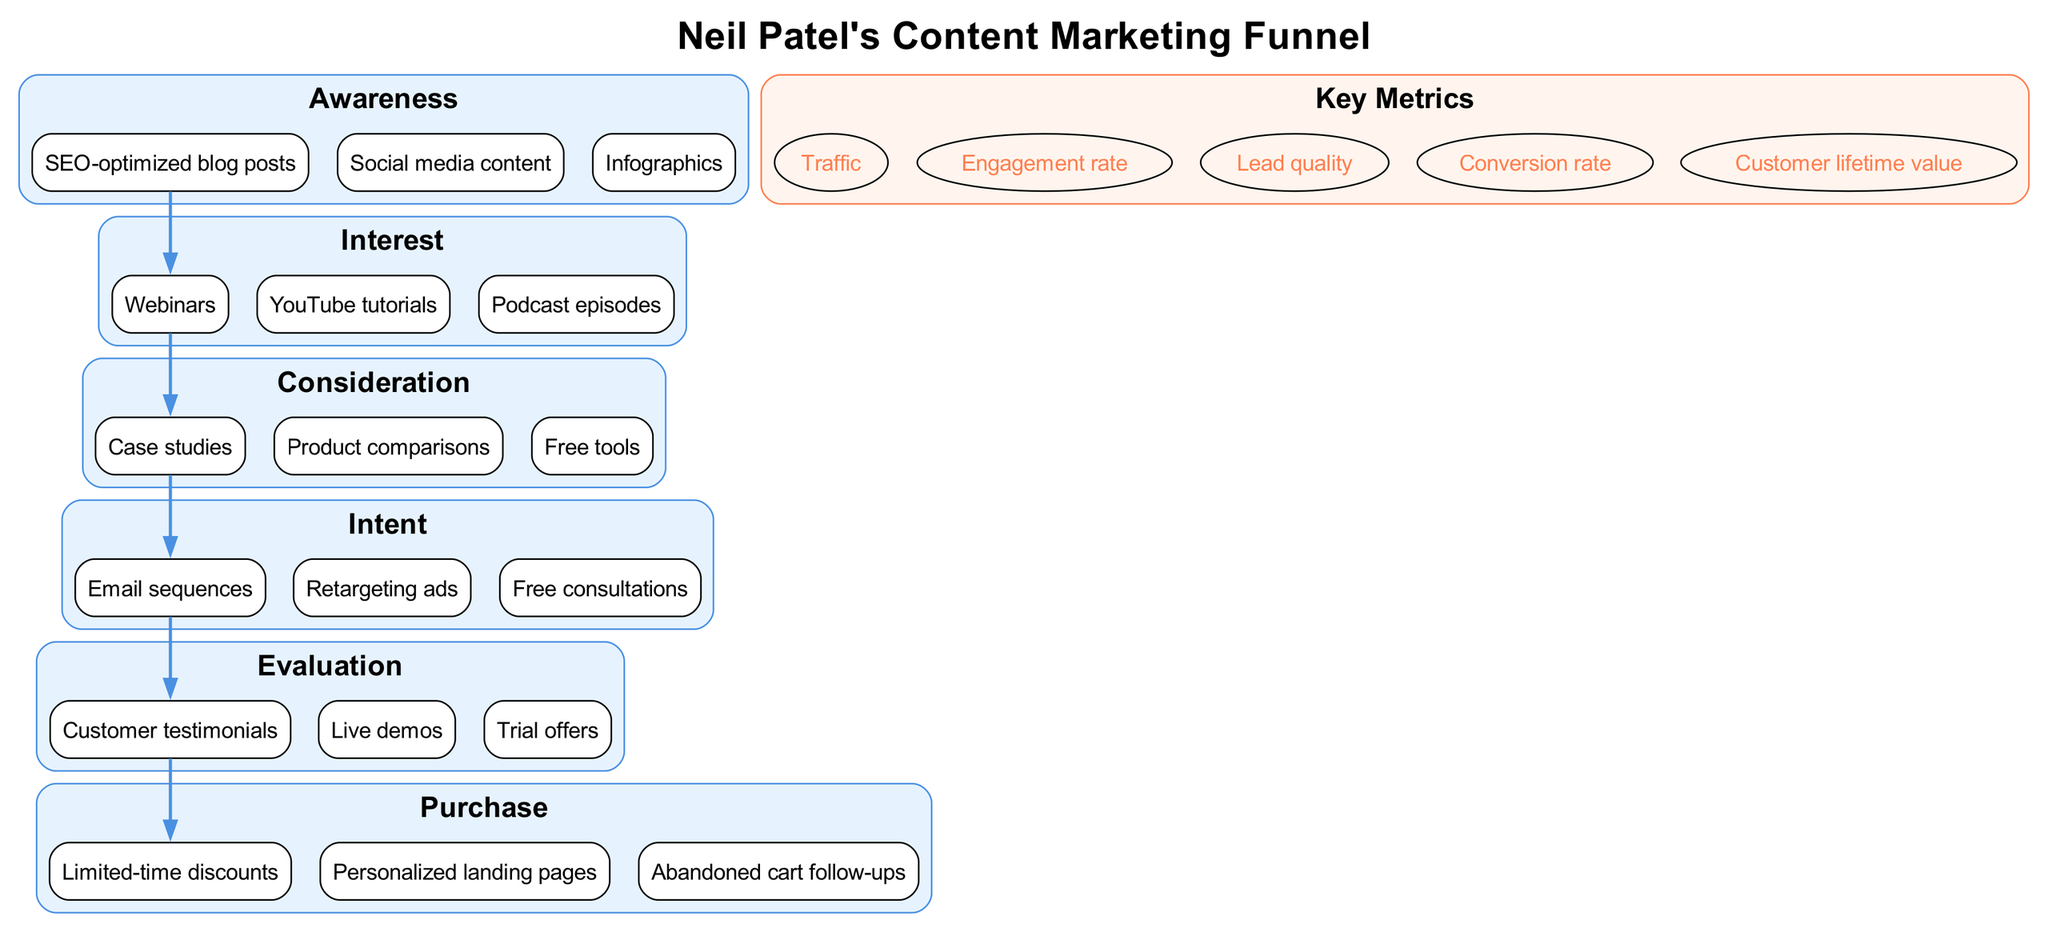What are the stages in the content marketing funnel? The content marketing funnel consists of several stages: Awareness, Interest, Consideration, Intent, Evaluation, and Purchase. Each stage has specific content types associated with it, which can be identified in the diagram.
Answer: Awareness, Interest, Consideration, Intent, Evaluation, Purchase Which content types are listed under the Interest stage? The Interest stage contains specific content types that engage potential customers. By reviewing the Interest section of the diagram, these content types can be directly identified as webinars, YouTube tutorials, and podcast episodes.
Answer: Webinars, YouTube tutorials, Podcast episodes How many content types are included in the Consideration stage? To answer this, we look at the number of content types listed under the Consideration stage in the diagram. The stage contains three specific types of content: case studies, product comparisons, and free tools, thus totaling three.
Answer: 3 What key metric is shown alongside the stages in the funnel? The diagram mentions key metrics that are relevant to the content marketing funnel. One of these key metrics is the conversion rate, which can be found in the metrics section of the diagram.
Answer: Conversion rate Which stage is immediately before the Purchase stage? The diagram illustrates a flow where each stage leads to the next. By observing the arrangement, we see that the Evaluation stage comes just before the Purchase stage in the sequence.
Answer: Evaluation What kind of content is highlighted in the Intent stage? In the Intent stage, the diagram specifies particular content types designed to convert potential leads into customers. These consist of email sequences, retargeting ads, and free consultations, directly listed in this section.
Answer: Email sequences, Retargeting ads, Free consultations How many total stages are present in the content marketing funnel? By counting the stages represented in the diagram, we find that there are a total of six distinct stages displayed, from Awareness to Purchase.
Answer: 6 Which metric focuses on customer retention over time? The diagram lists several metrics related to the funnel's performance. Among these, customer lifetime value pertains specifically to customer retention and revenue generation over a customer's lifespan.
Answer: Customer lifetime value 